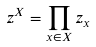Convert formula to latex. <formula><loc_0><loc_0><loc_500><loc_500>z ^ { X } = \prod _ { x \in X } z _ { x }</formula> 